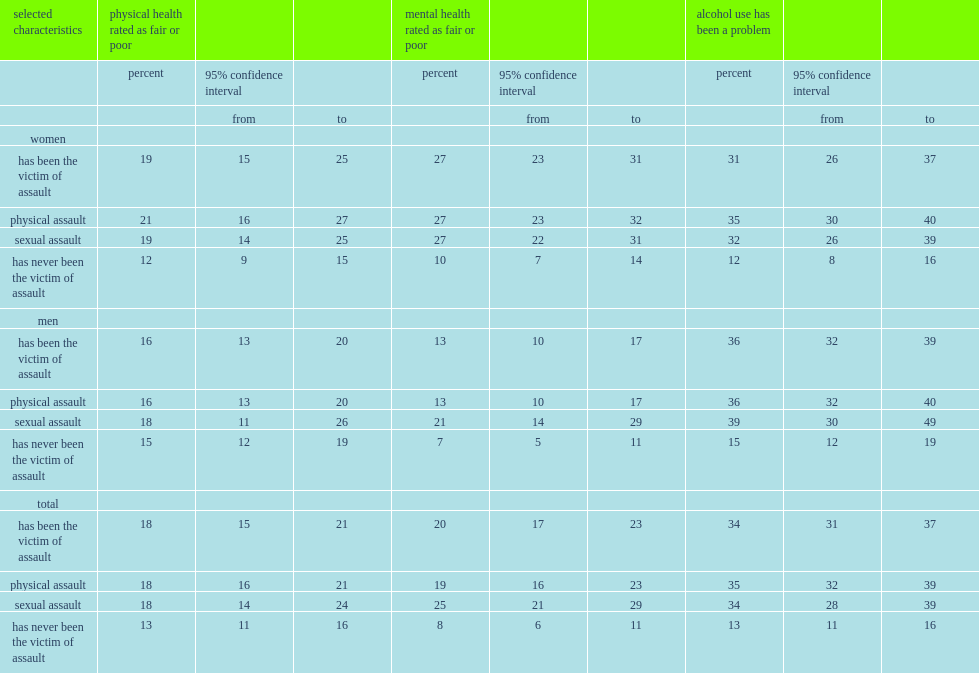Who were more likely to rate their physical or mental health negatively,those who had been victims of assault or not? Has been the victim of assault. What was the percentage of women who had been assaulted since the age of 15 rated their physical health as fair or poor? 19.0. What was the percentage of women victims reported that their drinking had been a source of problems with others? 31.0. What was the percentage of women who had never been victims of assault reported that their drinking had been a source of problems with others? 12.0. Who were more likely to have used alcohol in ways that caused problems with others,men who had been assaulted or those not? Has been the victim of assault. 